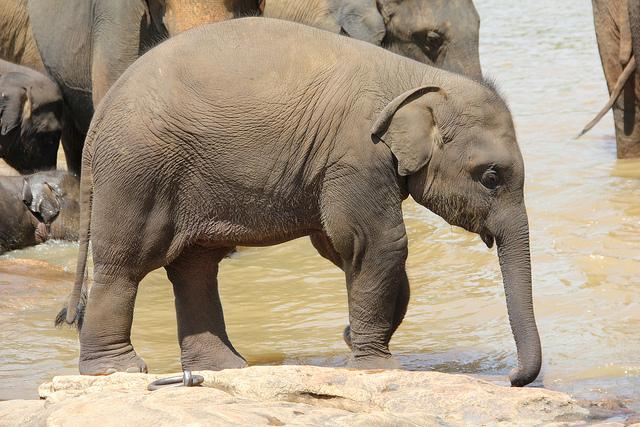Is there an elephant near the fence?
Give a very brief answer. No. Does this baby elephant have a trunk?
Be succinct. Yes. Who took this?
Be succinct. Photographer. Are the elephants in a zoo?
Short answer required. No. How many elephants are there?
Keep it brief. 2. How many animals are there?
Short answer required. 4. 